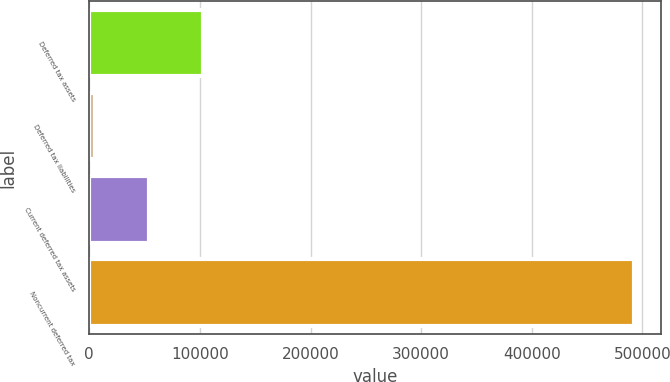Convert chart to OTSL. <chart><loc_0><loc_0><loc_500><loc_500><bar_chart><fcel>Deferred tax assets<fcel>Deferred tax liabilities<fcel>Current deferred tax assets<fcel>Noncurrent deferred tax<nl><fcel>102586<fcel>5117<fcel>53851.7<fcel>492464<nl></chart> 